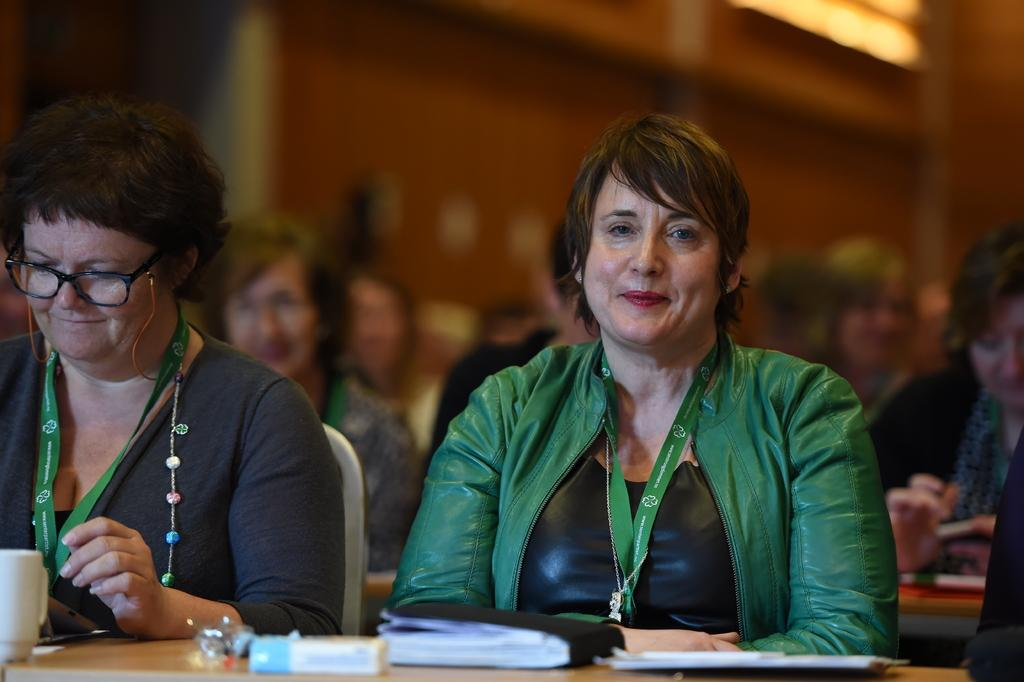What are the people in the image doing? There are persons sitting at the table in the image. What can be seen on the table besides the people? There is a cup, books, and a pad on the table. Are there any other people visible in the image? Yes, there are persons in the background of the image. What is visible in the background of the image? There is a wall in the background of the image. What type of cow can be seen in the image? There is no cow present in the image. How does the sponge contribute to the scene in the image? There is no sponge present in the image. 